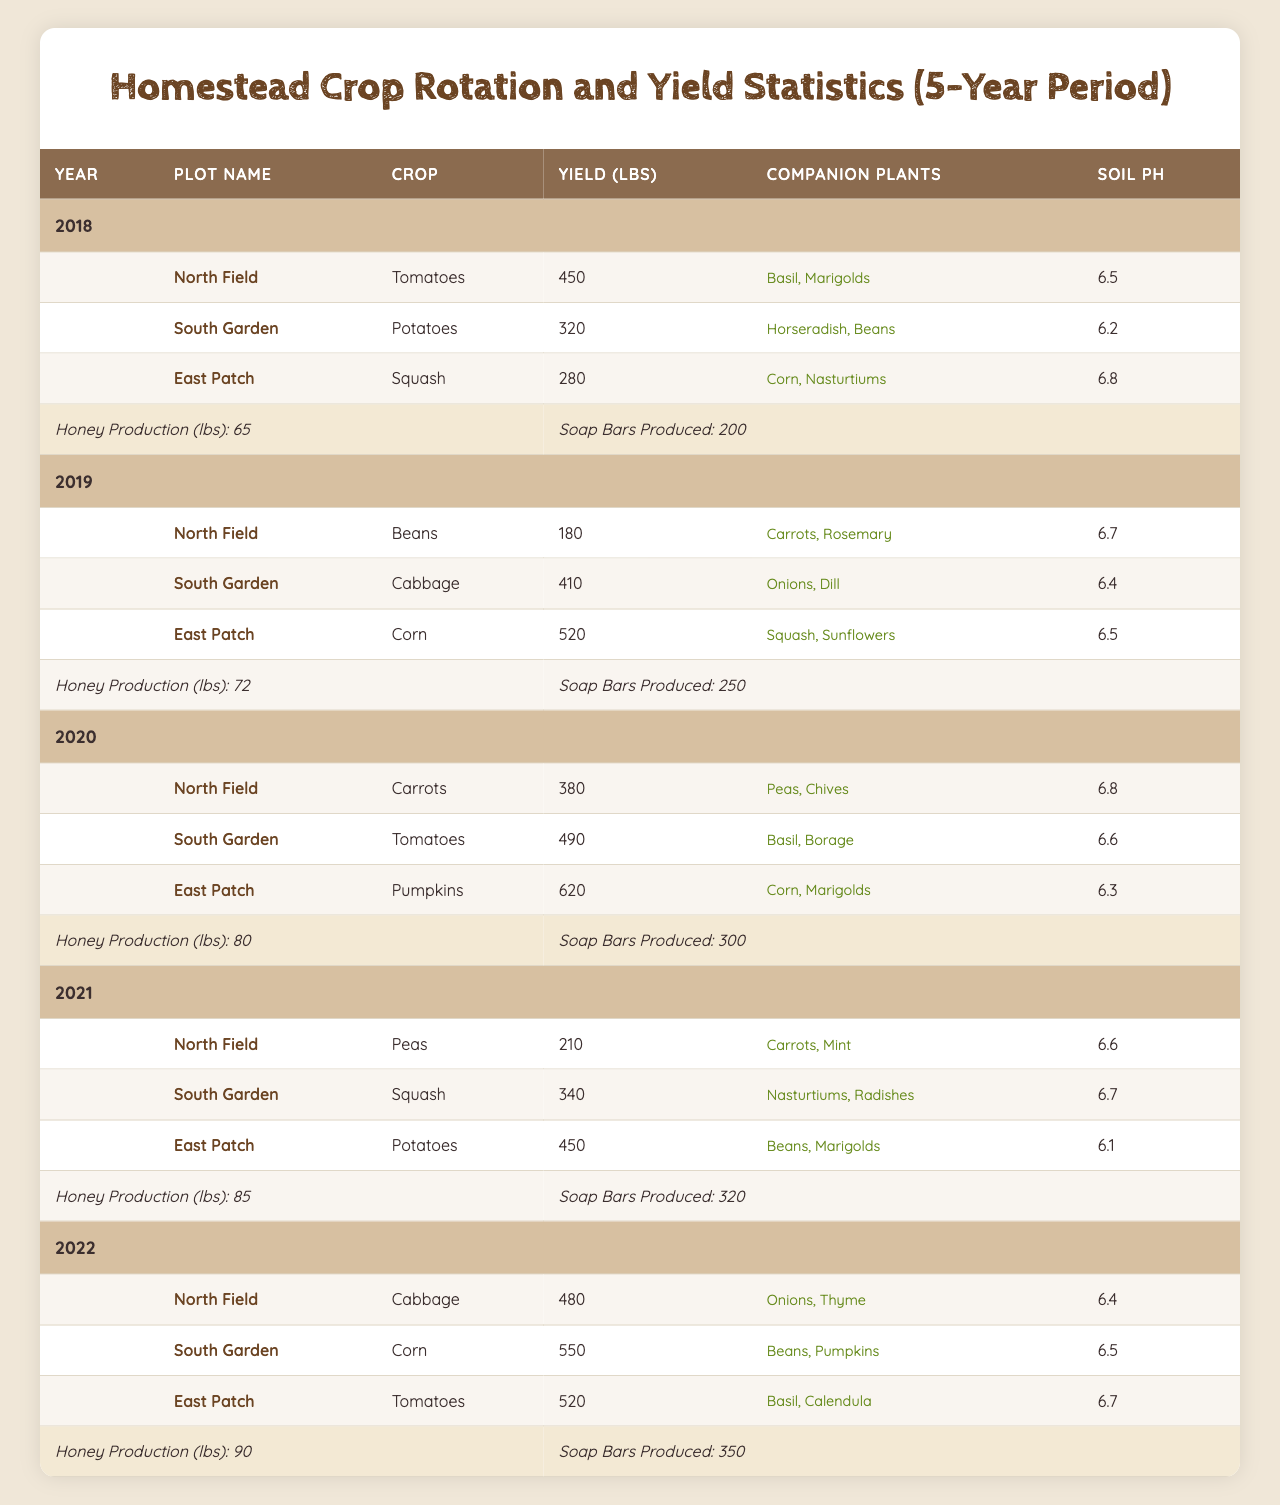What was the total honey production over the 5-year period? The honey production for each year is: 65 (2018), 72 (2019), 80 (2020), 85 (2021), and 90 (2022). Adding these values: 65 + 72 + 80 + 85 + 90 = 392 lbs.
Answer: 392 lbs Which crop yielded the highest amount in 2020? In 2020, the highest yield was for Pumpkins from the East Patch with 620 lbs, compared to 490 lbs for Tomatoes and 380 lbs for Carrots.
Answer: Pumpkins Did the North Field ever grow Tomatoes? The North Field grew Tomatoes in 2018 with a yield of 450 lbs.
Answer: Yes What is the average yield of crops grown in the South Garden over the 5 years? The yields in the South Garden are: 320 (2018), 410 (2019), 490 (2020), 340 (2021), and 550 (2022). The total is 320 + 410 + 490 + 340 + 550 = 2100 lbs, and the average is 2100 / 5 = 420 lbs.
Answer: 420 lbs In what year did the East Patch grow Corn and what was the yield? The East Patch grew Corn in 2019 with a yield of 520 lbs. This is shown in the year 2019 of the data.
Answer: 2019, 520 lbs Which crop had the most significant increase in yield from 2019 to 2020, and what was the increase? In 2019, the East Patch grew Corn with a yield of 520 lbs, and in 2020, it grew Pumpkins with a yield of 620 lbs. The increase is 620 - 520 = 100 lbs.
Answer: Pumpkins, 100 lbs What was the total yield for crops in the North Field over the entire period? The yields in the North Field are: 450 (2018), 180 (2019), 380 (2020), 210 (2021), and 480 (2022). Summing these gives 450 + 180 + 380 + 210 + 480 = 1700 lbs.
Answer: 1700 lbs Which year had the highest number of Soap Bars produced? The year 2022 had the highest production of Soap Bars, with a total of 350 bars, compared to 200 in 2018, 250 in 2019, 300 in 2020, and 320 in 2021.
Answer: 2022 Did any year have a decrease in both honey production and soap bars produced compared to the previous year? Yes, from 2020 to 2021, honey production increased from 80 to 85 lbs, but soap bars decreased from 300 to 320 bars. However, no year shows both decreasing trends as honey production increased each year.
Answer: No What is the average soil pH for the crops grown in 2021? The soil pH values for crops in 2021 are: 6.6 (Peas), 6.7 (Squash), and 6.1 (Potatoes). Averaging these gives (6.6 + 6.7 + 6.1) / 3 = 6.4667, roughly 6.47 when rounded.
Answer: 6.47 